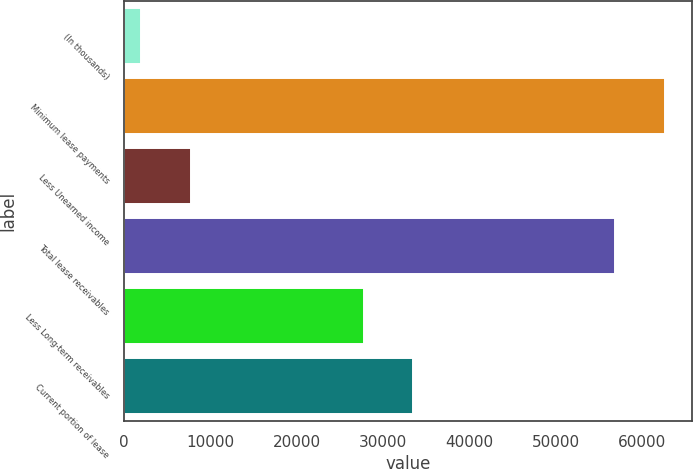Convert chart. <chart><loc_0><loc_0><loc_500><loc_500><bar_chart><fcel>(In thousands)<fcel>Minimum lease payments<fcel>Less Unearned income<fcel>Total lease receivables<fcel>Less Long-term receivables<fcel>Current portion of lease<nl><fcel>2016<fcel>62633.5<fcel>7731.5<fcel>56918<fcel>27790<fcel>33505.5<nl></chart> 